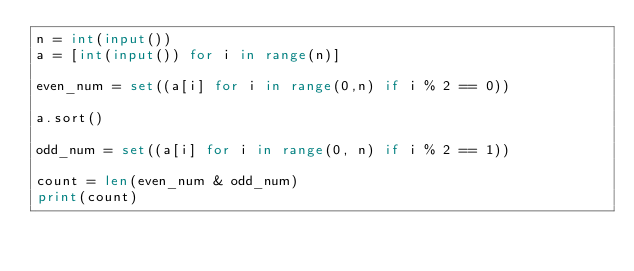<code> <loc_0><loc_0><loc_500><loc_500><_Python_>n = int(input())
a = [int(input()) for i in range(n)]

even_num = set((a[i] for i in range(0,n) if i % 2 == 0))

a.sort()

odd_num = set((a[i] for i in range(0, n) if i % 2 == 1))

count = len(even_num & odd_num)
print(count)
</code> 